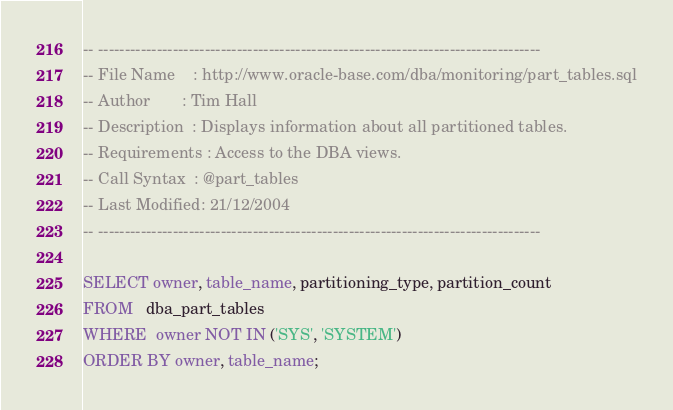Convert code to text. <code><loc_0><loc_0><loc_500><loc_500><_SQL_>-- -----------------------------------------------------------------------------------
-- File Name    : http://www.oracle-base.com/dba/monitoring/part_tables.sql
-- Author       : Tim Hall
-- Description  : Displays information about all partitioned tables.
-- Requirements : Access to the DBA views.
-- Call Syntax  : @part_tables
-- Last Modified: 21/12/2004
-- -----------------------------------------------------------------------------------

SELECT owner, table_name, partitioning_type, partition_count
FROM   dba_part_tables
WHERE  owner NOT IN ('SYS', 'SYSTEM')
ORDER BY owner, table_name;
</code> 